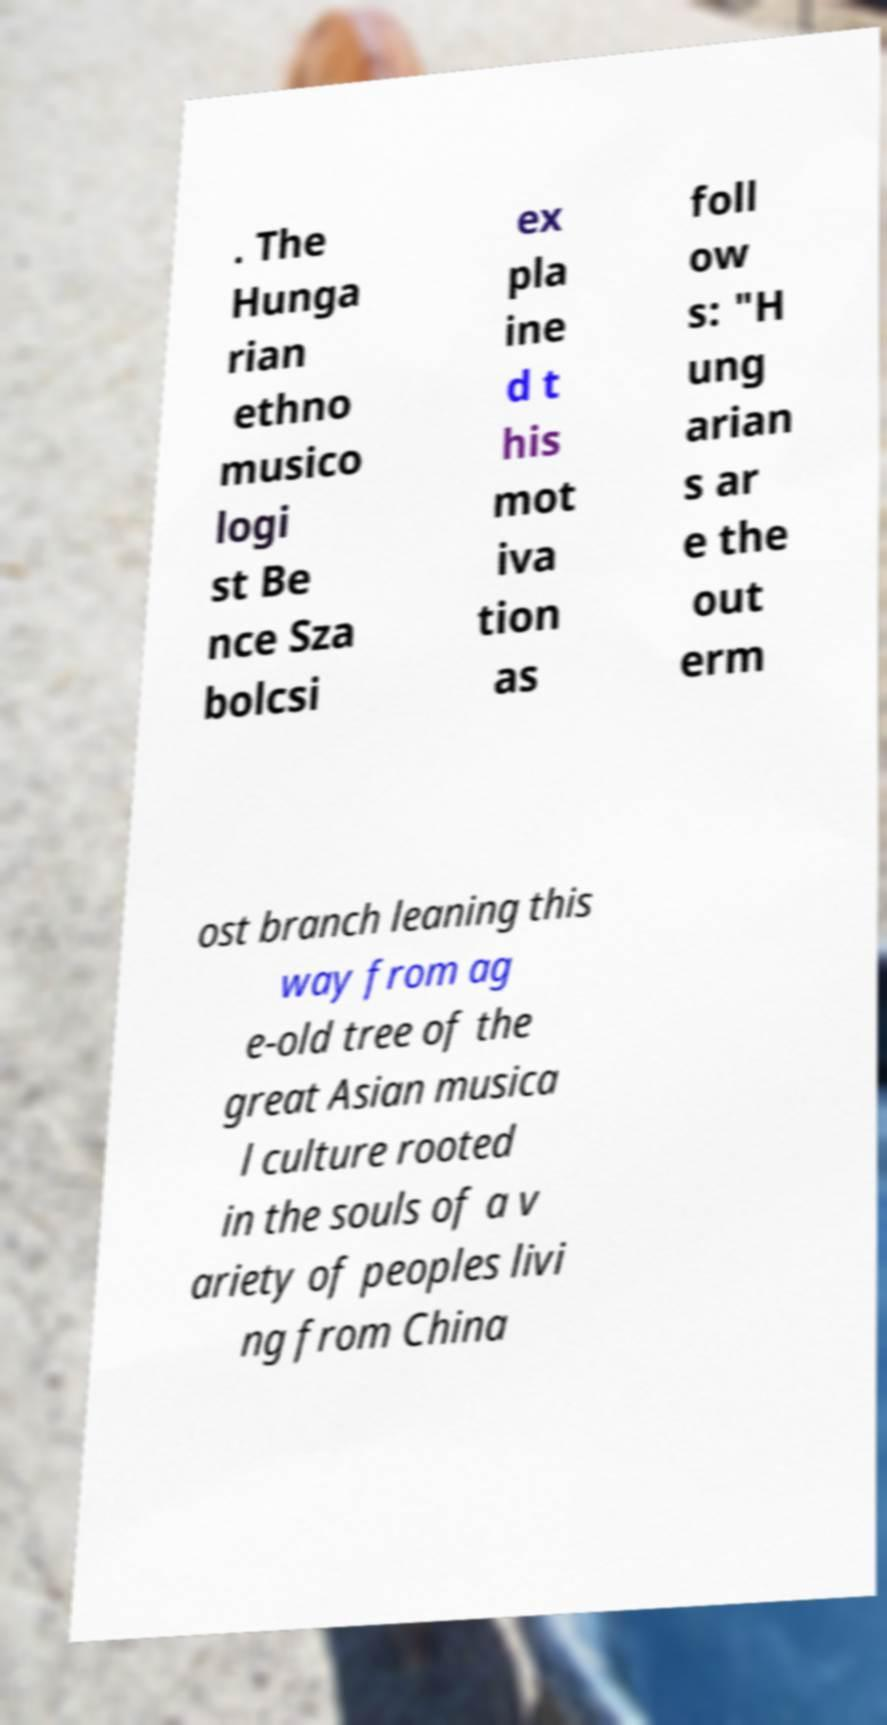For documentation purposes, I need the text within this image transcribed. Could you provide that? . The Hunga rian ethno musico logi st Be nce Sza bolcsi ex pla ine d t his mot iva tion as foll ow s: "H ung arian s ar e the out erm ost branch leaning this way from ag e-old tree of the great Asian musica l culture rooted in the souls of a v ariety of peoples livi ng from China 